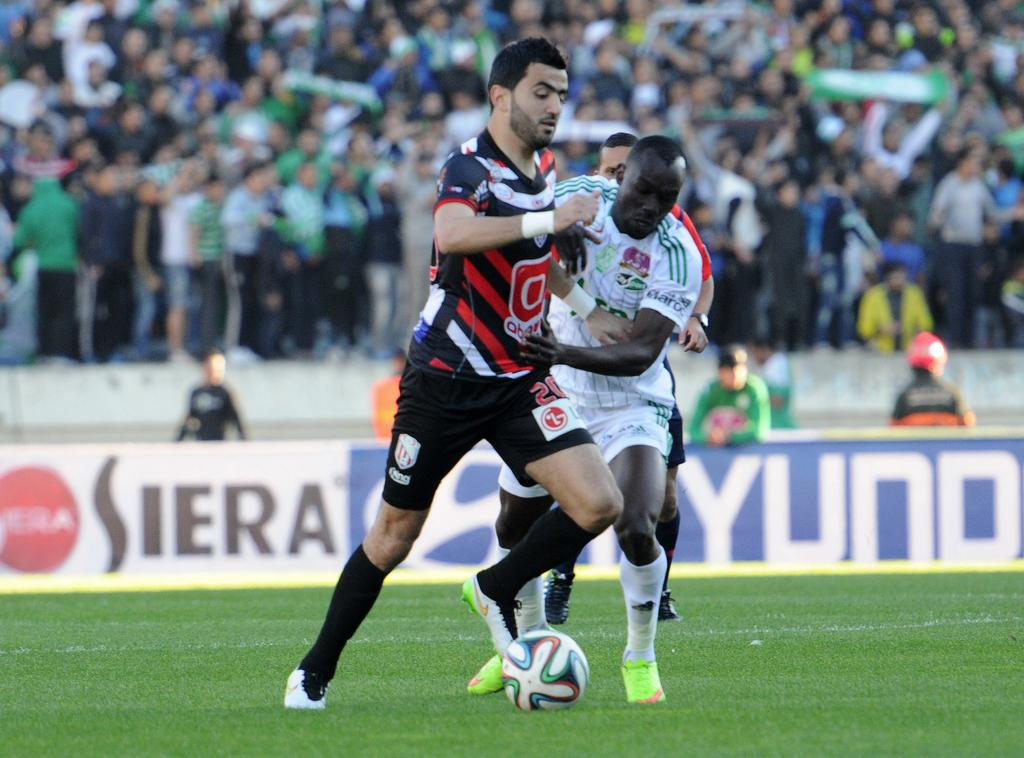What sport are the players in the image participating in? The players are playing football. Where is the football game taking place? The football game is taking place on a ground. Who else is present in the image besides the players? There are spectators in the image. What are the spectators doing in the image? The spectators are watching the football match. How does the boy untie the knot in the image? There is no boy or knot present in the image. 